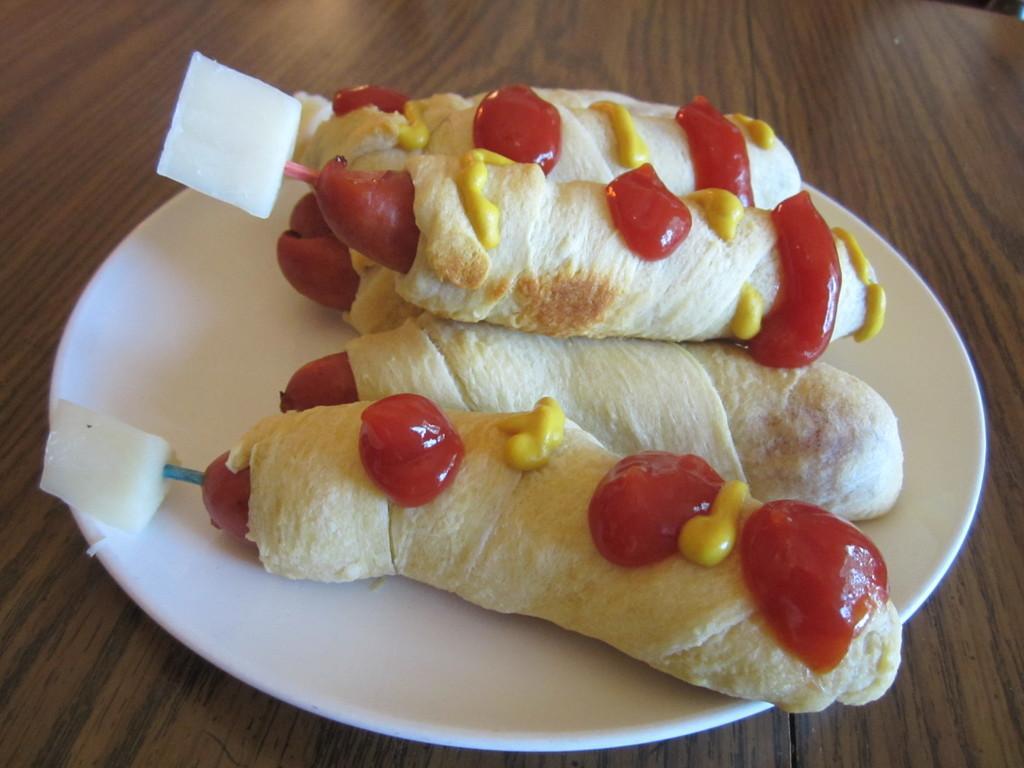How would you summarize this image in a sentence or two? In this picture I can see some food item kept in a plate and placed on the wooden surface. 